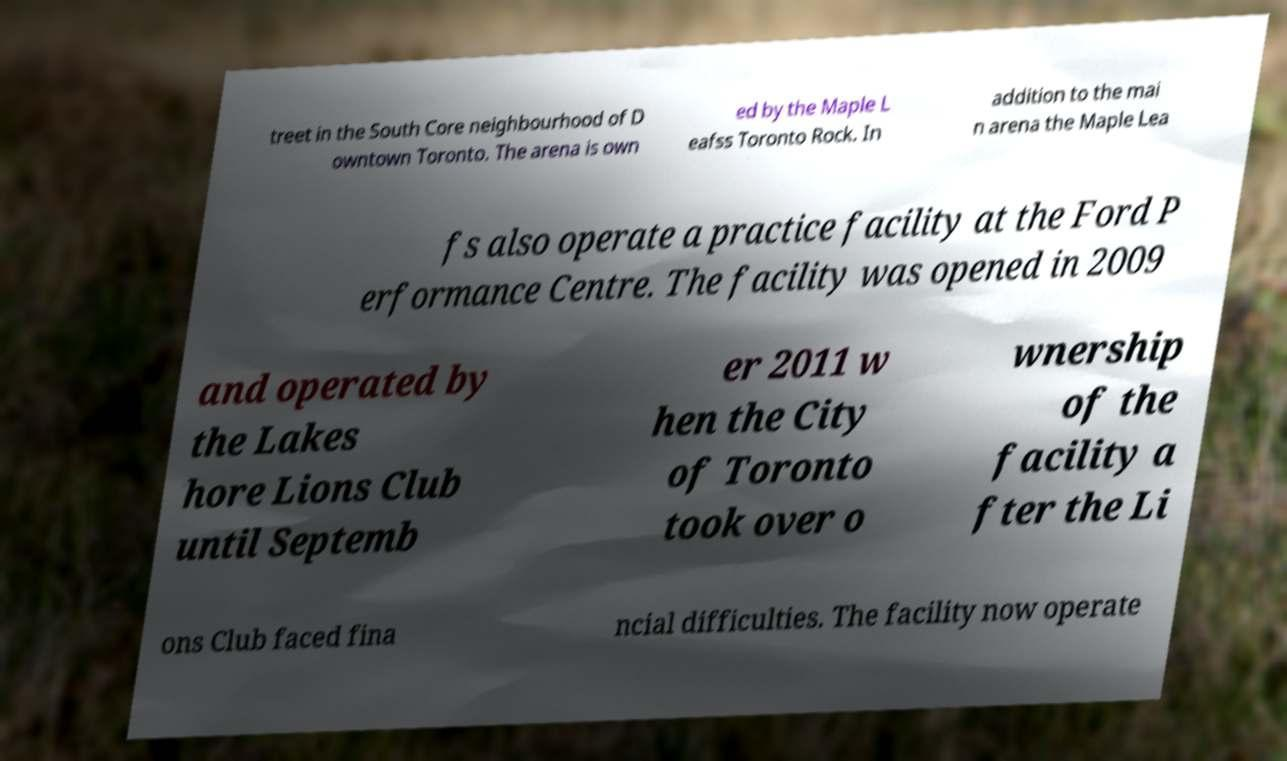Could you extract and type out the text from this image? treet in the South Core neighbourhood of D owntown Toronto. The arena is own ed by the Maple L eafss Toronto Rock. In addition to the mai n arena the Maple Lea fs also operate a practice facility at the Ford P erformance Centre. The facility was opened in 2009 and operated by the Lakes hore Lions Club until Septemb er 2011 w hen the City of Toronto took over o wnership of the facility a fter the Li ons Club faced fina ncial difficulties. The facility now operate 